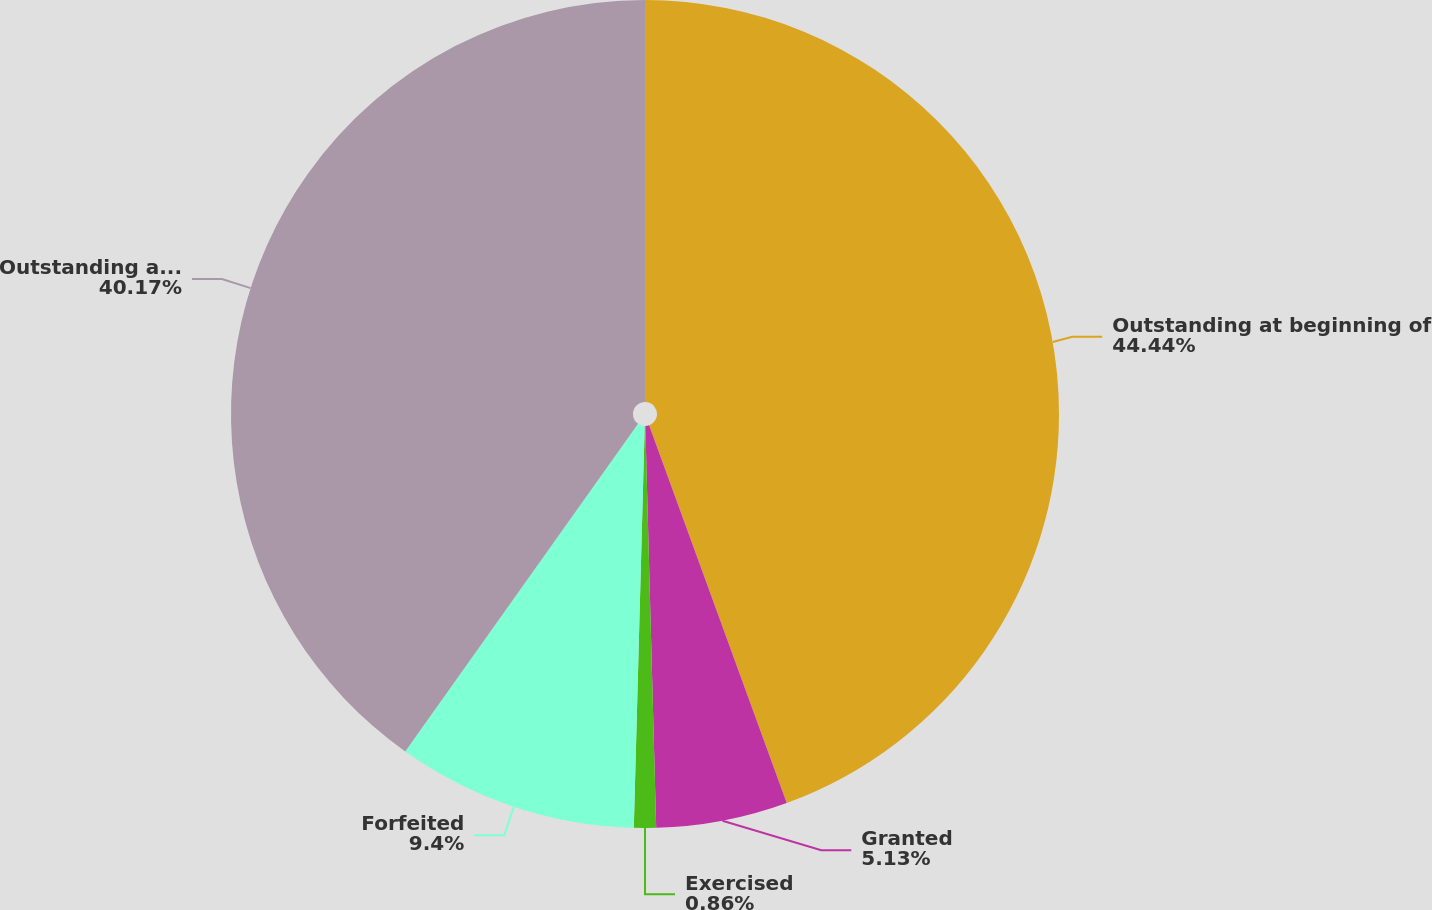Convert chart. <chart><loc_0><loc_0><loc_500><loc_500><pie_chart><fcel>Outstanding at beginning of<fcel>Granted<fcel>Exercised<fcel>Forfeited<fcel>Outstanding at year-end<nl><fcel>44.43%<fcel>5.13%<fcel>0.86%<fcel>9.4%<fcel>40.16%<nl></chart> 